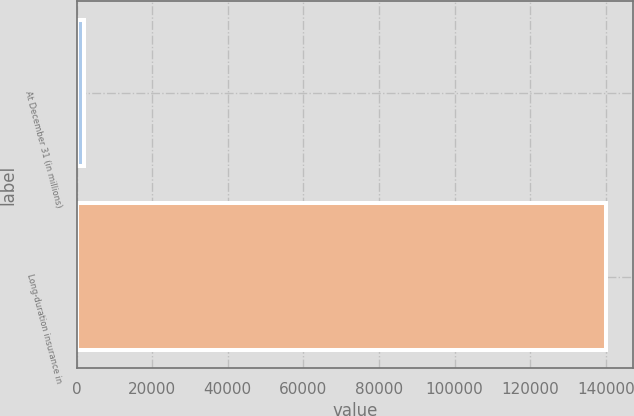<chart> <loc_0><loc_0><loc_500><loc_500><bar_chart><fcel>At December 31 (in millions)<fcel>Long-duration insurance in<nl><fcel>2011<fcel>140156<nl></chart> 